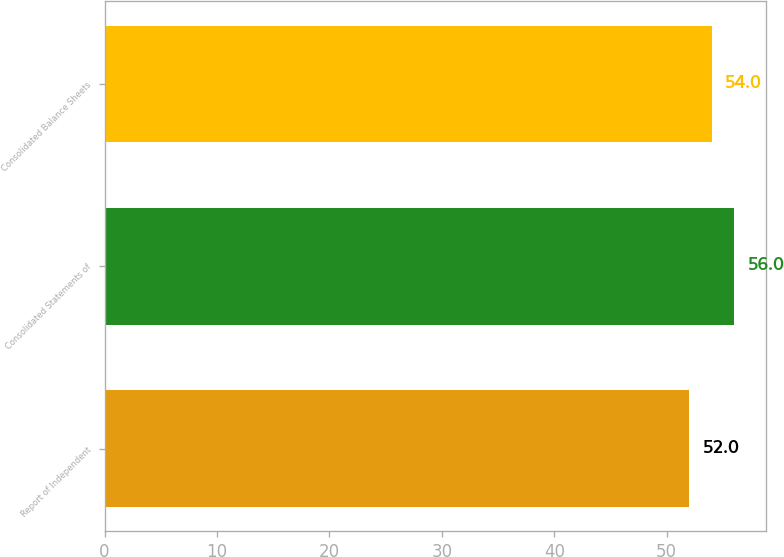Convert chart. <chart><loc_0><loc_0><loc_500><loc_500><bar_chart><fcel>Report of Independent<fcel>Consolidated Statements of<fcel>Consolidated Balance Sheets<nl><fcel>52<fcel>56<fcel>54<nl></chart> 